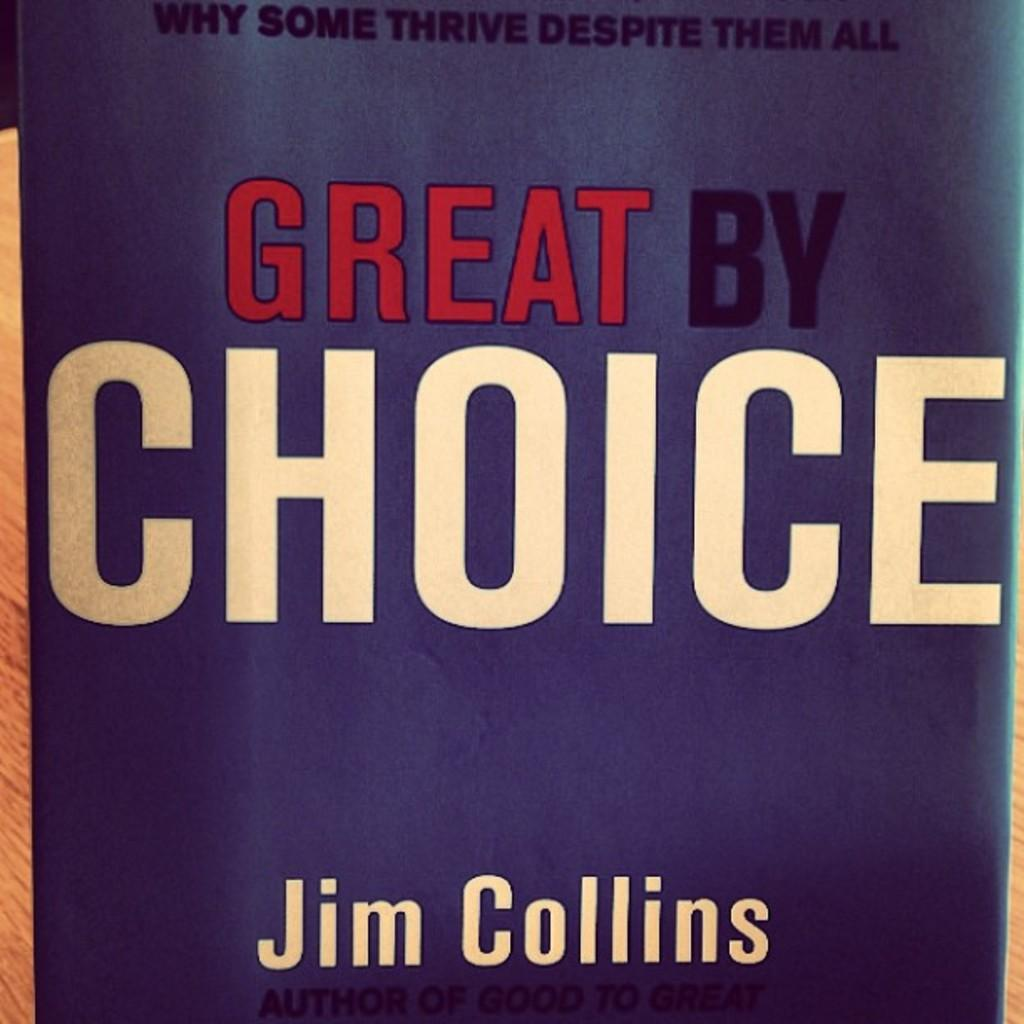<image>
Write a terse but informative summary of the picture. The book pictured is called Great By Choice by Jim Collins 